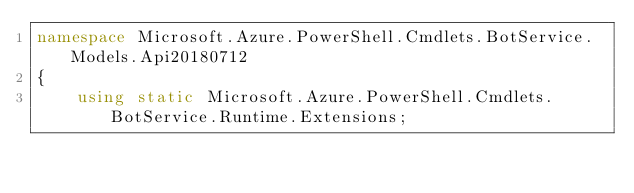<code> <loc_0><loc_0><loc_500><loc_500><_C#_>namespace Microsoft.Azure.PowerShell.Cmdlets.BotService.Models.Api20180712
{
    using static Microsoft.Azure.PowerShell.Cmdlets.BotService.Runtime.Extensions;
</code> 